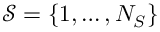<formula> <loc_0><loc_0><loc_500><loc_500>{ \mathcal { S } } = \{ 1 , \dots , N _ { S } \}</formula> 